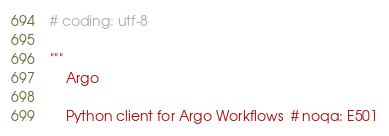<code> <loc_0><loc_0><loc_500><loc_500><_Python_># coding: utf-8

"""
    Argo

    Python client for Argo Workflows  # noqa: E501
</code> 